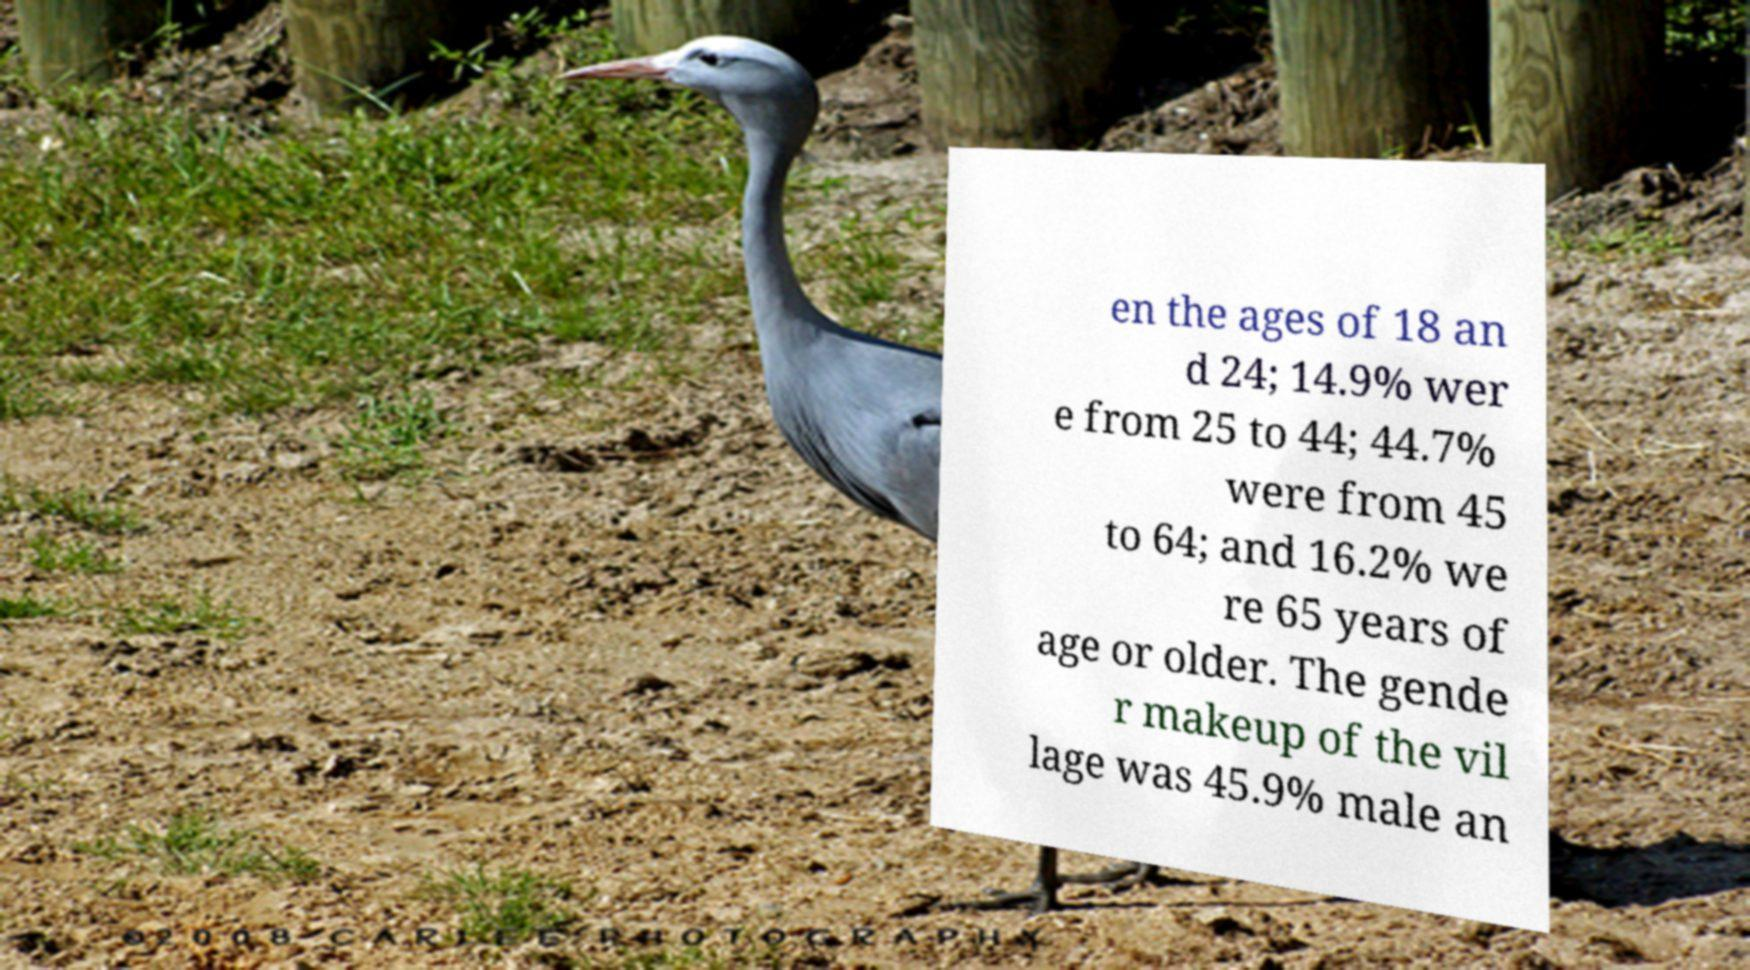Could you extract and type out the text from this image? en the ages of 18 an d 24; 14.9% wer e from 25 to 44; 44.7% were from 45 to 64; and 16.2% we re 65 years of age or older. The gende r makeup of the vil lage was 45.9% male an 